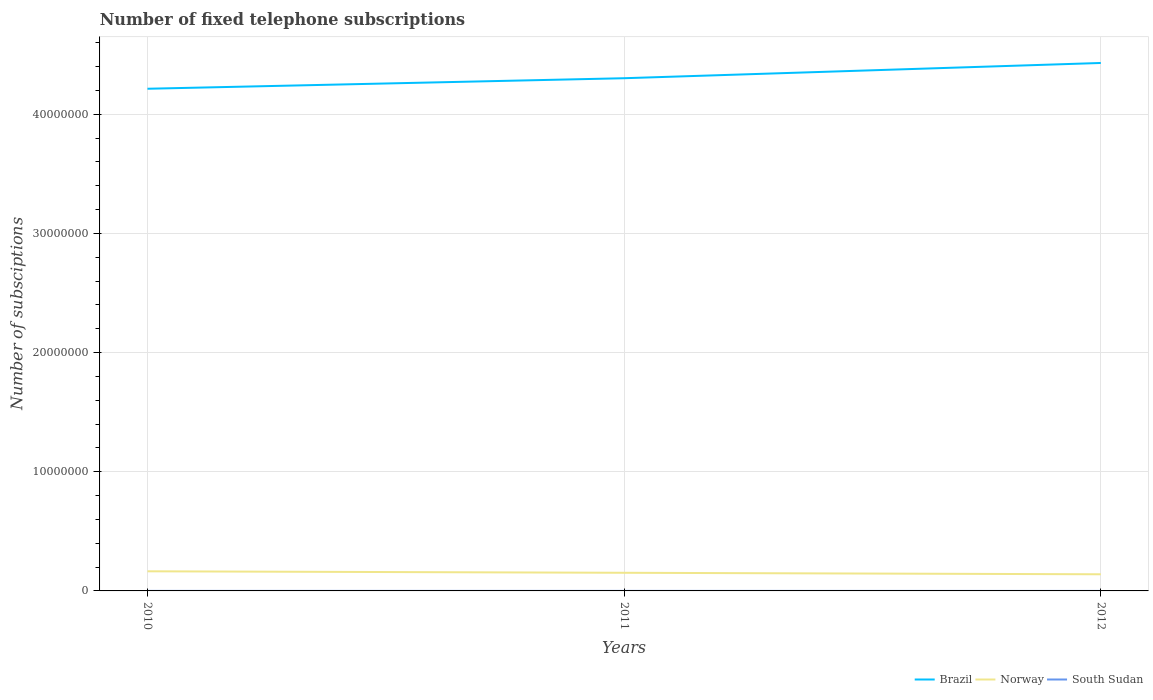Does the line corresponding to Norway intersect with the line corresponding to Brazil?
Offer a very short reply. No. Is the number of lines equal to the number of legend labels?
Ensure brevity in your answer.  Yes. Across all years, what is the maximum number of fixed telephone subscriptions in South Sudan?
Offer a terse response. 150. What is the total number of fixed telephone subscriptions in South Sudan in the graph?
Ensure brevity in your answer.  200. What is the difference between the highest and the second highest number of fixed telephone subscriptions in Brazil?
Offer a terse response. 2.16e+06. How many lines are there?
Provide a succinct answer. 3. What is the difference between two consecutive major ticks on the Y-axis?
Ensure brevity in your answer.  1.00e+07. Are the values on the major ticks of Y-axis written in scientific E-notation?
Keep it short and to the point. No. Does the graph contain any zero values?
Your answer should be compact. No. Does the graph contain grids?
Your response must be concise. Yes. Where does the legend appear in the graph?
Give a very brief answer. Bottom right. What is the title of the graph?
Your answer should be compact. Number of fixed telephone subscriptions. Does "Central Europe" appear as one of the legend labels in the graph?
Your response must be concise. No. What is the label or title of the X-axis?
Make the answer very short. Years. What is the label or title of the Y-axis?
Give a very brief answer. Number of subsciptions. What is the Number of subsciptions of Brazil in 2010?
Offer a very short reply. 4.21e+07. What is the Number of subsciptions of Norway in 2010?
Provide a succinct answer. 1.65e+06. What is the Number of subsciptions in South Sudan in 2010?
Ensure brevity in your answer.  2400. What is the Number of subsciptions of Brazil in 2011?
Make the answer very short. 4.30e+07. What is the Number of subsciptions of Norway in 2011?
Keep it short and to the point. 1.52e+06. What is the Number of subsciptions in South Sudan in 2011?
Provide a succinct answer. 2200. What is the Number of subsciptions in Brazil in 2012?
Your answer should be compact. 4.43e+07. What is the Number of subsciptions in Norway in 2012?
Keep it short and to the point. 1.40e+06. What is the Number of subsciptions in South Sudan in 2012?
Offer a very short reply. 150. Across all years, what is the maximum Number of subsciptions in Brazil?
Make the answer very short. 4.43e+07. Across all years, what is the maximum Number of subsciptions of Norway?
Your response must be concise. 1.65e+06. Across all years, what is the maximum Number of subsciptions of South Sudan?
Make the answer very short. 2400. Across all years, what is the minimum Number of subsciptions in Brazil?
Your response must be concise. 4.21e+07. Across all years, what is the minimum Number of subsciptions of Norway?
Your answer should be compact. 1.40e+06. Across all years, what is the minimum Number of subsciptions of South Sudan?
Offer a terse response. 150. What is the total Number of subsciptions in Brazil in the graph?
Ensure brevity in your answer.  1.29e+08. What is the total Number of subsciptions of Norway in the graph?
Your answer should be very brief. 4.57e+06. What is the total Number of subsciptions of South Sudan in the graph?
Your answer should be compact. 4750. What is the difference between the Number of subsciptions in Brazil in 2010 and that in 2011?
Ensure brevity in your answer.  -8.84e+05. What is the difference between the Number of subsciptions of Norway in 2010 and that in 2011?
Offer a terse response. 1.25e+05. What is the difference between the Number of subsciptions of South Sudan in 2010 and that in 2011?
Keep it short and to the point. 200. What is the difference between the Number of subsciptions in Brazil in 2010 and that in 2012?
Provide a succinct answer. -2.16e+06. What is the difference between the Number of subsciptions of Norway in 2010 and that in 2012?
Your answer should be very brief. 2.51e+05. What is the difference between the Number of subsciptions in South Sudan in 2010 and that in 2012?
Provide a succinct answer. 2250. What is the difference between the Number of subsciptions in Brazil in 2011 and that in 2012?
Your answer should be very brief. -1.28e+06. What is the difference between the Number of subsciptions of Norway in 2011 and that in 2012?
Provide a short and direct response. 1.26e+05. What is the difference between the Number of subsciptions in South Sudan in 2011 and that in 2012?
Your answer should be very brief. 2050. What is the difference between the Number of subsciptions of Brazil in 2010 and the Number of subsciptions of Norway in 2011?
Keep it short and to the point. 4.06e+07. What is the difference between the Number of subsciptions in Brazil in 2010 and the Number of subsciptions in South Sudan in 2011?
Your answer should be very brief. 4.21e+07. What is the difference between the Number of subsciptions in Norway in 2010 and the Number of subsciptions in South Sudan in 2011?
Offer a very short reply. 1.65e+06. What is the difference between the Number of subsciptions in Brazil in 2010 and the Number of subsciptions in Norway in 2012?
Your answer should be very brief. 4.07e+07. What is the difference between the Number of subsciptions in Brazil in 2010 and the Number of subsciptions in South Sudan in 2012?
Provide a short and direct response. 4.21e+07. What is the difference between the Number of subsciptions of Norway in 2010 and the Number of subsciptions of South Sudan in 2012?
Provide a succinct answer. 1.65e+06. What is the difference between the Number of subsciptions of Brazil in 2011 and the Number of subsciptions of Norway in 2012?
Your answer should be very brief. 4.16e+07. What is the difference between the Number of subsciptions in Brazil in 2011 and the Number of subsciptions in South Sudan in 2012?
Offer a terse response. 4.30e+07. What is the difference between the Number of subsciptions in Norway in 2011 and the Number of subsciptions in South Sudan in 2012?
Keep it short and to the point. 1.52e+06. What is the average Number of subsciptions in Brazil per year?
Provide a succinct answer. 4.32e+07. What is the average Number of subsciptions in Norway per year?
Offer a terse response. 1.52e+06. What is the average Number of subsciptions of South Sudan per year?
Offer a very short reply. 1583.33. In the year 2010, what is the difference between the Number of subsciptions of Brazil and Number of subsciptions of Norway?
Your answer should be very brief. 4.05e+07. In the year 2010, what is the difference between the Number of subsciptions in Brazil and Number of subsciptions in South Sudan?
Offer a terse response. 4.21e+07. In the year 2010, what is the difference between the Number of subsciptions of Norway and Number of subsciptions of South Sudan?
Provide a short and direct response. 1.64e+06. In the year 2011, what is the difference between the Number of subsciptions of Brazil and Number of subsciptions of Norway?
Ensure brevity in your answer.  4.15e+07. In the year 2011, what is the difference between the Number of subsciptions in Brazil and Number of subsciptions in South Sudan?
Provide a succinct answer. 4.30e+07. In the year 2011, what is the difference between the Number of subsciptions of Norway and Number of subsciptions of South Sudan?
Make the answer very short. 1.52e+06. In the year 2012, what is the difference between the Number of subsciptions in Brazil and Number of subsciptions in Norway?
Your answer should be very brief. 4.29e+07. In the year 2012, what is the difference between the Number of subsciptions of Brazil and Number of subsciptions of South Sudan?
Your response must be concise. 4.43e+07. In the year 2012, what is the difference between the Number of subsciptions of Norway and Number of subsciptions of South Sudan?
Keep it short and to the point. 1.40e+06. What is the ratio of the Number of subsciptions in Brazil in 2010 to that in 2011?
Keep it short and to the point. 0.98. What is the ratio of the Number of subsciptions in Norway in 2010 to that in 2011?
Your response must be concise. 1.08. What is the ratio of the Number of subsciptions of South Sudan in 2010 to that in 2011?
Your response must be concise. 1.09. What is the ratio of the Number of subsciptions of Brazil in 2010 to that in 2012?
Your response must be concise. 0.95. What is the ratio of the Number of subsciptions in Norway in 2010 to that in 2012?
Your answer should be very brief. 1.18. What is the ratio of the Number of subsciptions of Brazil in 2011 to that in 2012?
Your answer should be compact. 0.97. What is the ratio of the Number of subsciptions of Norway in 2011 to that in 2012?
Your answer should be compact. 1.09. What is the ratio of the Number of subsciptions of South Sudan in 2011 to that in 2012?
Provide a succinct answer. 14.67. What is the difference between the highest and the second highest Number of subsciptions in Brazil?
Offer a very short reply. 1.28e+06. What is the difference between the highest and the second highest Number of subsciptions of Norway?
Provide a short and direct response. 1.25e+05. What is the difference between the highest and the second highest Number of subsciptions in South Sudan?
Offer a terse response. 200. What is the difference between the highest and the lowest Number of subsciptions of Brazil?
Your answer should be compact. 2.16e+06. What is the difference between the highest and the lowest Number of subsciptions in Norway?
Offer a very short reply. 2.51e+05. What is the difference between the highest and the lowest Number of subsciptions of South Sudan?
Offer a very short reply. 2250. 